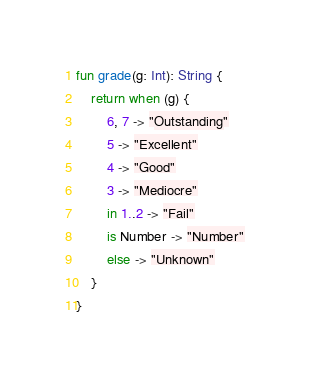Convert code to text. <code><loc_0><loc_0><loc_500><loc_500><_Kotlin_>fun grade(g: Int): String {
    return when (g) {
        6, 7 -> "Outstanding"
        5 -> "Excellent"
        4 -> "Good"
        3 -> "Mediocre"
        in 1..2 -> "Fail"
        is Number -> "Number"
        else -> "Unknown"
    }
}</code> 